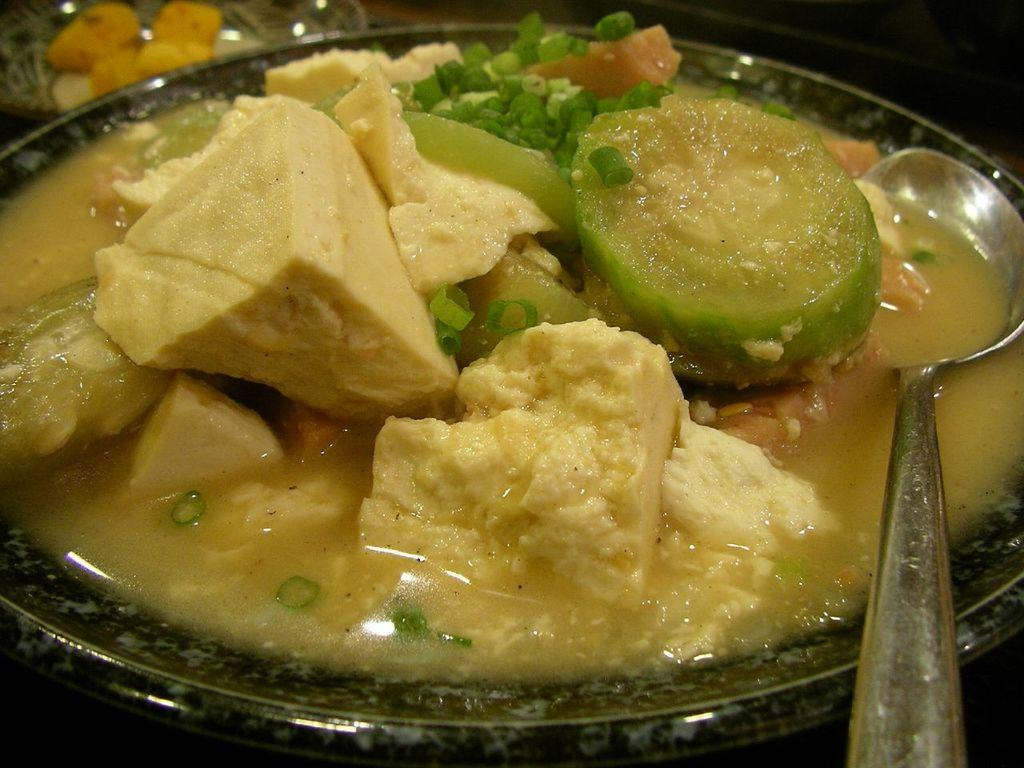What is in the bowl that is visible in the image? The bowl contains chili pieces, butter, soup, and vegetables. What utensil is present in the bowl? There is a spoon in the bowl. Where is the bowl located in the image? The bowl is placed on a table. What type of government is depicted in the image? There is no depiction of a government in the image; it features a bowl with various ingredients and a spoon. 